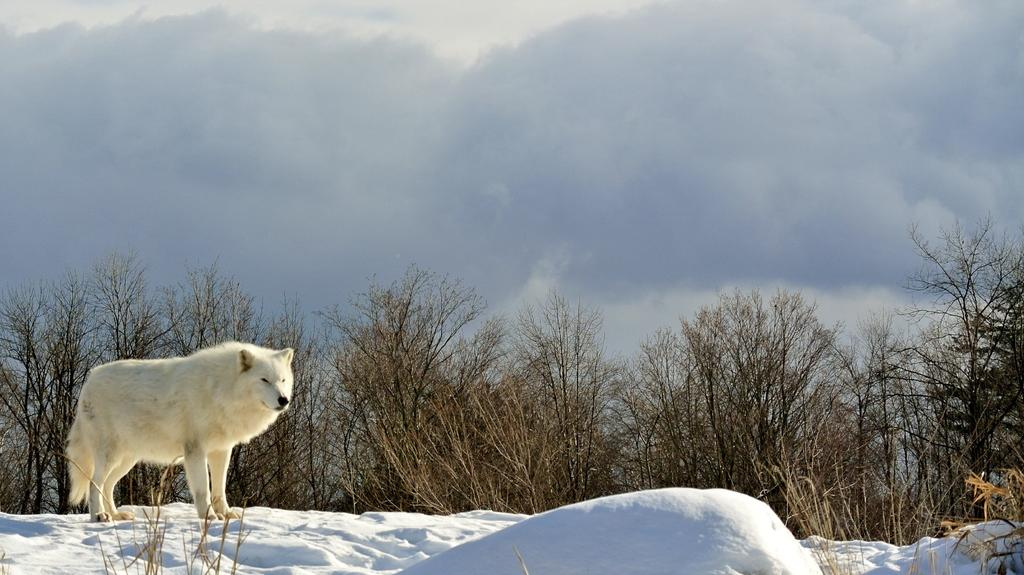What animal is located on the left side of the image? There is a wolf on the left side of the image. What type of terrain is depicted at the bottom of the image? There is snow at the bottom of the image. What can be seen in the background of the image? There are trees in the background of the image. How would you describe the sky in the image? The sky is cloudy in the image. What type of day is it in the image? The provided facts do not mention the time of day or any specific weather conditions, so it is impossible to determine the type of day in the image. 